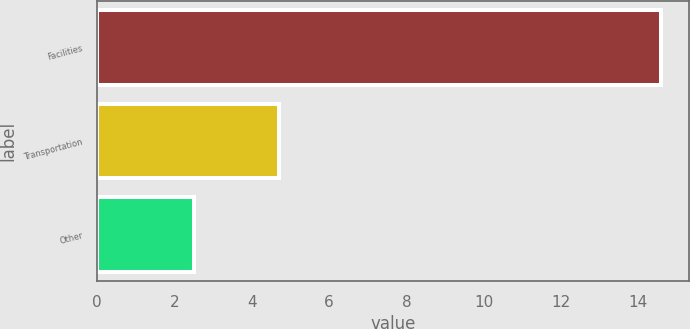Convert chart to OTSL. <chart><loc_0><loc_0><loc_500><loc_500><bar_chart><fcel>Facilities<fcel>Transportation<fcel>Other<nl><fcel>14.6<fcel>4.7<fcel>2.5<nl></chart> 